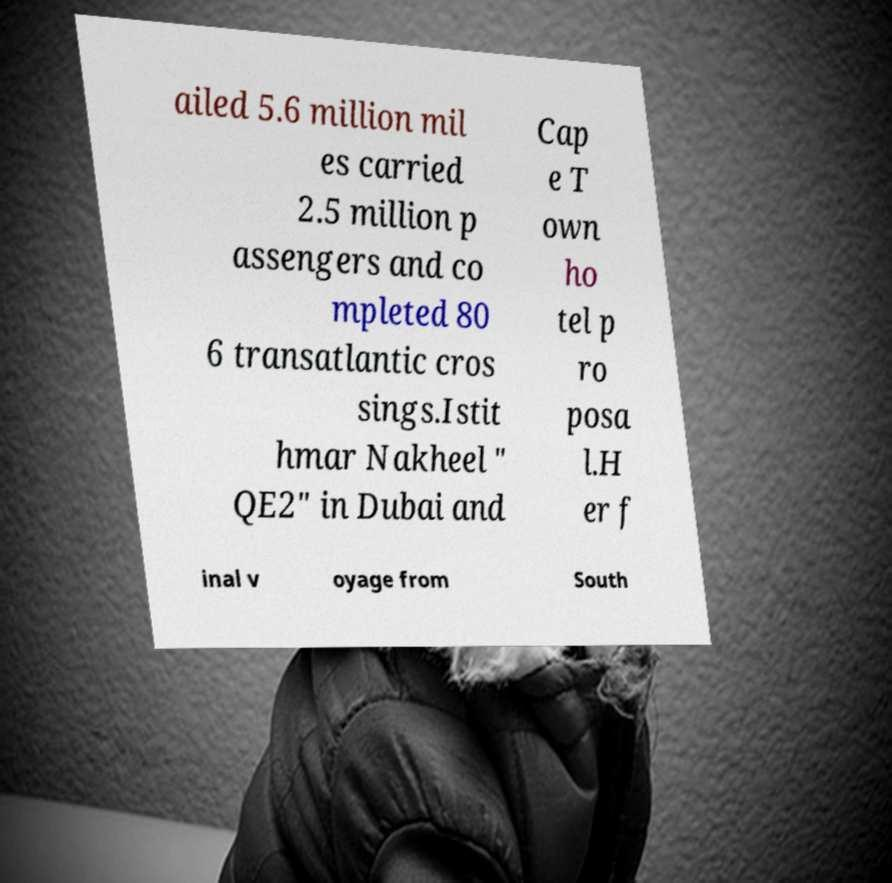Please identify and transcribe the text found in this image. ailed 5.6 million mil es carried 2.5 million p assengers and co mpleted 80 6 transatlantic cros sings.Istit hmar Nakheel " QE2" in Dubai and Cap e T own ho tel p ro posa l.H er f inal v oyage from South 